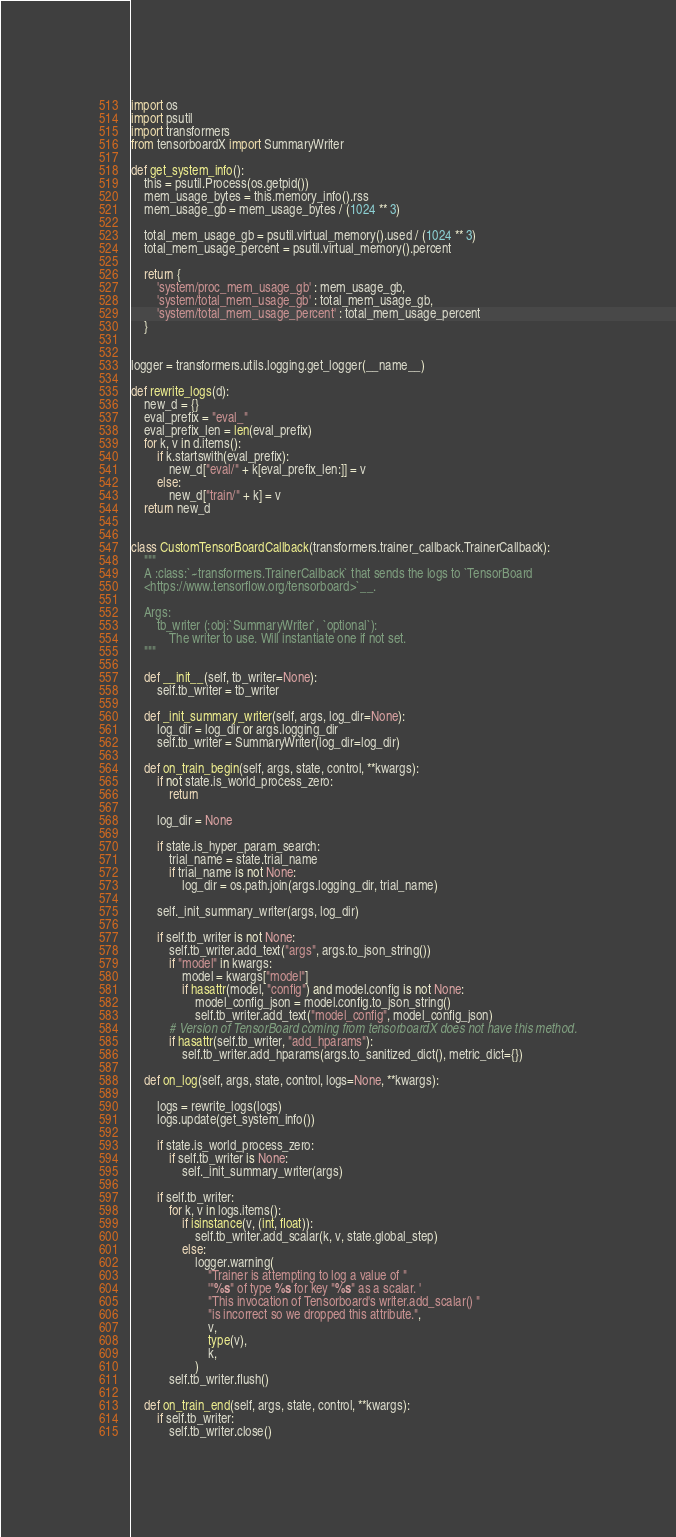Convert code to text. <code><loc_0><loc_0><loc_500><loc_500><_Python_>import os
import psutil
import transformers
from tensorboardX import SummaryWriter

def get_system_info():
    this = psutil.Process(os.getpid())
    mem_usage_bytes = this.memory_info().rss
    mem_usage_gb = mem_usage_bytes / (1024 ** 3)

    total_mem_usage_gb = psutil.virtual_memory().used / (1024 ** 3)
    total_mem_usage_percent = psutil.virtual_memory().percent

    return {
        'system/proc_mem_usage_gb' : mem_usage_gb,
        'system/total_mem_usage_gb' : total_mem_usage_gb,
        'system/total_mem_usage_percent' : total_mem_usage_percent
    }


logger = transformers.utils.logging.get_logger(__name__)

def rewrite_logs(d):
    new_d = {}
    eval_prefix = "eval_"
    eval_prefix_len = len(eval_prefix)
    for k, v in d.items():
        if k.startswith(eval_prefix):
            new_d["eval/" + k[eval_prefix_len:]] = v
        else:
            new_d["train/" + k] = v
    return new_d


class CustomTensorBoardCallback(transformers.trainer_callback.TrainerCallback):
    """
    A :class:`~transformers.TrainerCallback` that sends the logs to `TensorBoard
    <https://www.tensorflow.org/tensorboard>`__.

    Args:
        tb_writer (:obj:`SummaryWriter`, `optional`):
            The writer to use. Will instantiate one if not set.
    """

    def __init__(self, tb_writer=None):
        self.tb_writer = tb_writer

    def _init_summary_writer(self, args, log_dir=None):
        log_dir = log_dir or args.logging_dir
        self.tb_writer = SummaryWriter(log_dir=log_dir)

    def on_train_begin(self, args, state, control, **kwargs):
        if not state.is_world_process_zero:
            return

        log_dir = None

        if state.is_hyper_param_search:
            trial_name = state.trial_name
            if trial_name is not None:
                log_dir = os.path.join(args.logging_dir, trial_name)

        self._init_summary_writer(args, log_dir)

        if self.tb_writer is not None:
            self.tb_writer.add_text("args", args.to_json_string())
            if "model" in kwargs:
                model = kwargs["model"]
                if hasattr(model, "config") and model.config is not None:
                    model_config_json = model.config.to_json_string()
                    self.tb_writer.add_text("model_config", model_config_json)
            # Version of TensorBoard coming from tensorboardX does not have this method.
            if hasattr(self.tb_writer, "add_hparams"):
                self.tb_writer.add_hparams(args.to_sanitized_dict(), metric_dict={})

    def on_log(self, args, state, control, logs=None, **kwargs):

        logs = rewrite_logs(logs)
        logs.update(get_system_info())

        if state.is_world_process_zero:
            if self.tb_writer is None:
                self._init_summary_writer(args)

        if self.tb_writer:
            for k, v in logs.items():
                if isinstance(v, (int, float)):
                    self.tb_writer.add_scalar(k, v, state.global_step)
                else:
                    logger.warning(
                        "Trainer is attempting to log a value of "
                        '"%s" of type %s for key "%s" as a scalar. '
                        "This invocation of Tensorboard's writer.add_scalar() "
                        "is incorrect so we dropped this attribute.",
                        v,
                        type(v),
                        k,
                    )
            self.tb_writer.flush()

    def on_train_end(self, args, state, control, **kwargs):
        if self.tb_writer:
            self.tb_writer.close()
</code> 